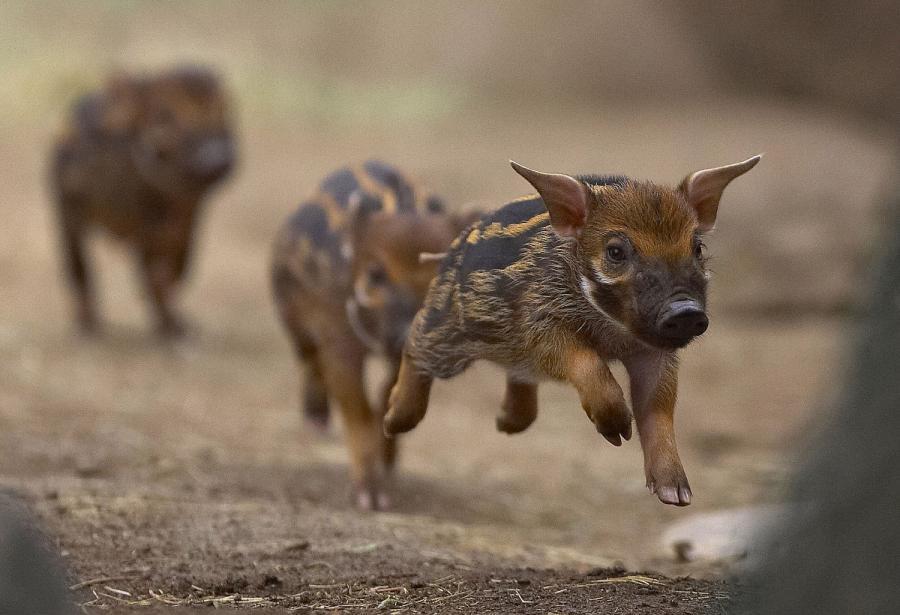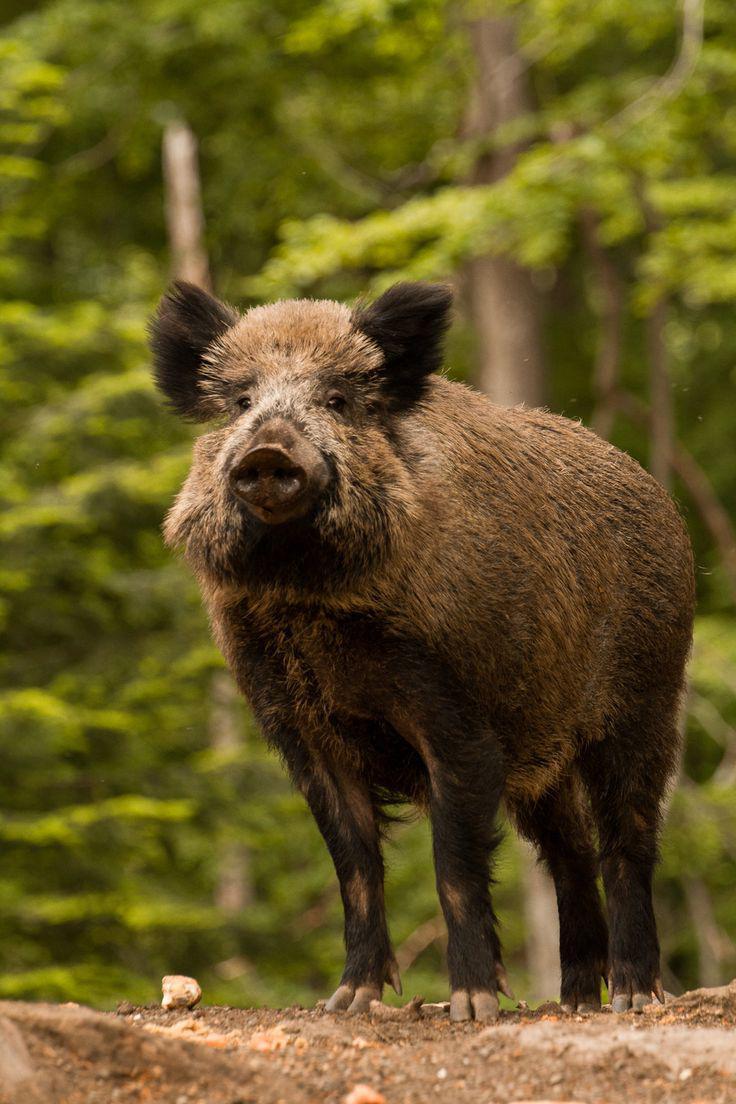The first image is the image on the left, the second image is the image on the right. Considering the images on both sides, is "The pig in the image on the right is near a body of water." valid? Answer yes or no. No. 